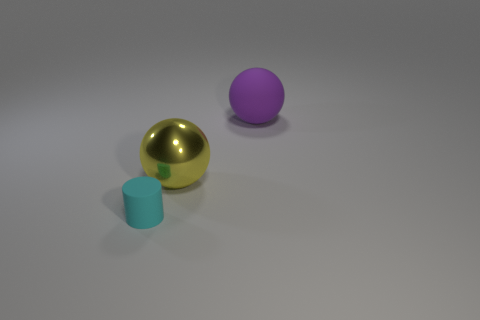Can you describe the lighting and shadows in the scene? The lighting in the image seems to come from above, as indicated by the shadows directly under the objects. The even, diffused shadows suggest a soft light source, creating a calm and simple atmosphere in the scene without harsh contrasts. 